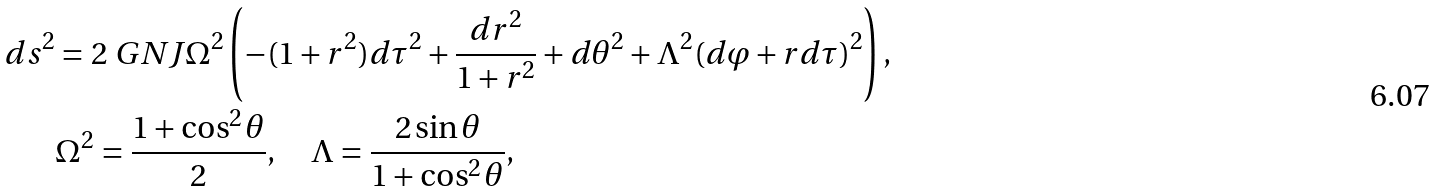Convert formula to latex. <formula><loc_0><loc_0><loc_500><loc_500>d s ^ { 2 } & = 2 \ G N J \Omega ^ { 2 } \left ( - ( 1 + r ^ { 2 } ) d \tau ^ { 2 } + \frac { d r ^ { 2 } } { 1 + r ^ { 2 } } + d \theta ^ { 2 } + \Lambda ^ { 2 } ( d \varphi + r d \tau ) ^ { 2 } \right ) , \\ & \Omega ^ { 2 } = \frac { 1 + \cos ^ { 2 } \theta } { 2 } , \quad \Lambda = \frac { 2 \sin \theta } { 1 + \cos ^ { 2 } \theta } ,</formula> 